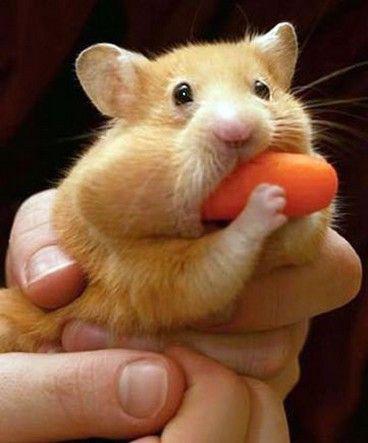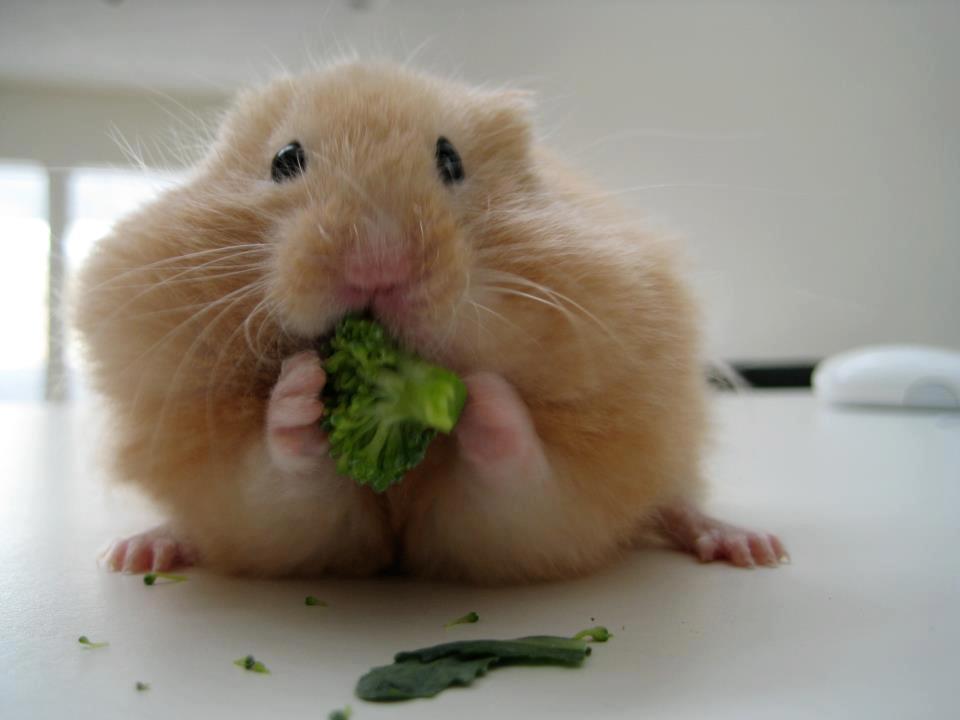The first image is the image on the left, the second image is the image on the right. For the images shown, is this caption "Each image shows a hamster that is eating." true? Answer yes or no. Yes. 